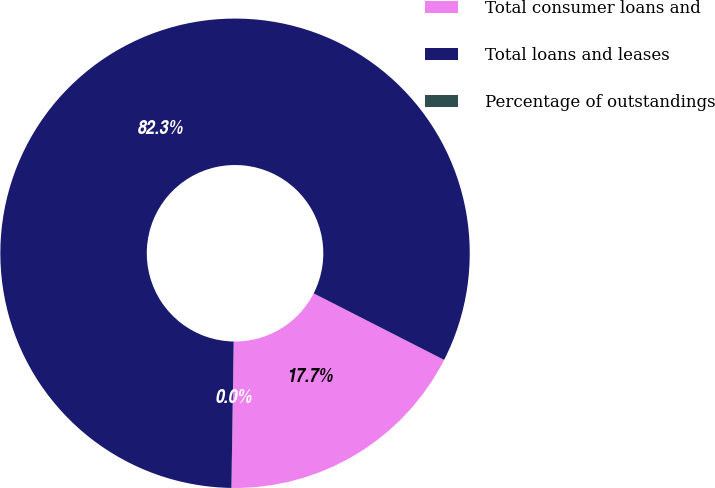<chart> <loc_0><loc_0><loc_500><loc_500><pie_chart><fcel>Total consumer loans and<fcel>Total loans and leases<fcel>Percentage of outstandings<nl><fcel>17.73%<fcel>82.26%<fcel>0.01%<nl></chart> 